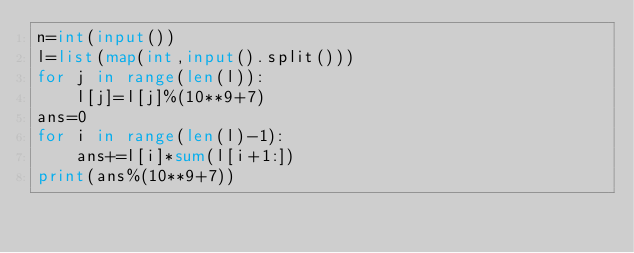<code> <loc_0><loc_0><loc_500><loc_500><_Python_>n=int(input())
l=list(map(int,input().split()))
for j in range(len(l)):
    l[j]=l[j]%(10**9+7)
ans=0
for i in range(len(l)-1):
    ans+=l[i]*sum(l[i+1:])
print(ans%(10**9+7))</code> 